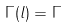<formula> <loc_0><loc_0><loc_500><loc_500>\Gamma ( l ) = \Gamma</formula> 